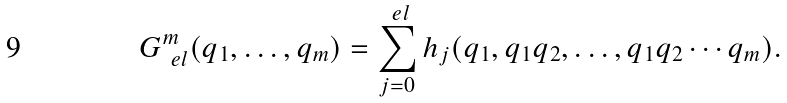<formula> <loc_0><loc_0><loc_500><loc_500>G ^ { m } _ { \ e l } ( q _ { 1 } , \dots , q _ { m } ) = \sum _ { j = 0 } ^ { \ e l } h _ { j } ( q _ { 1 } , q _ { 1 } q _ { 2 } , \dots , q _ { 1 } q _ { 2 } \cdots q _ { m } ) .</formula> 